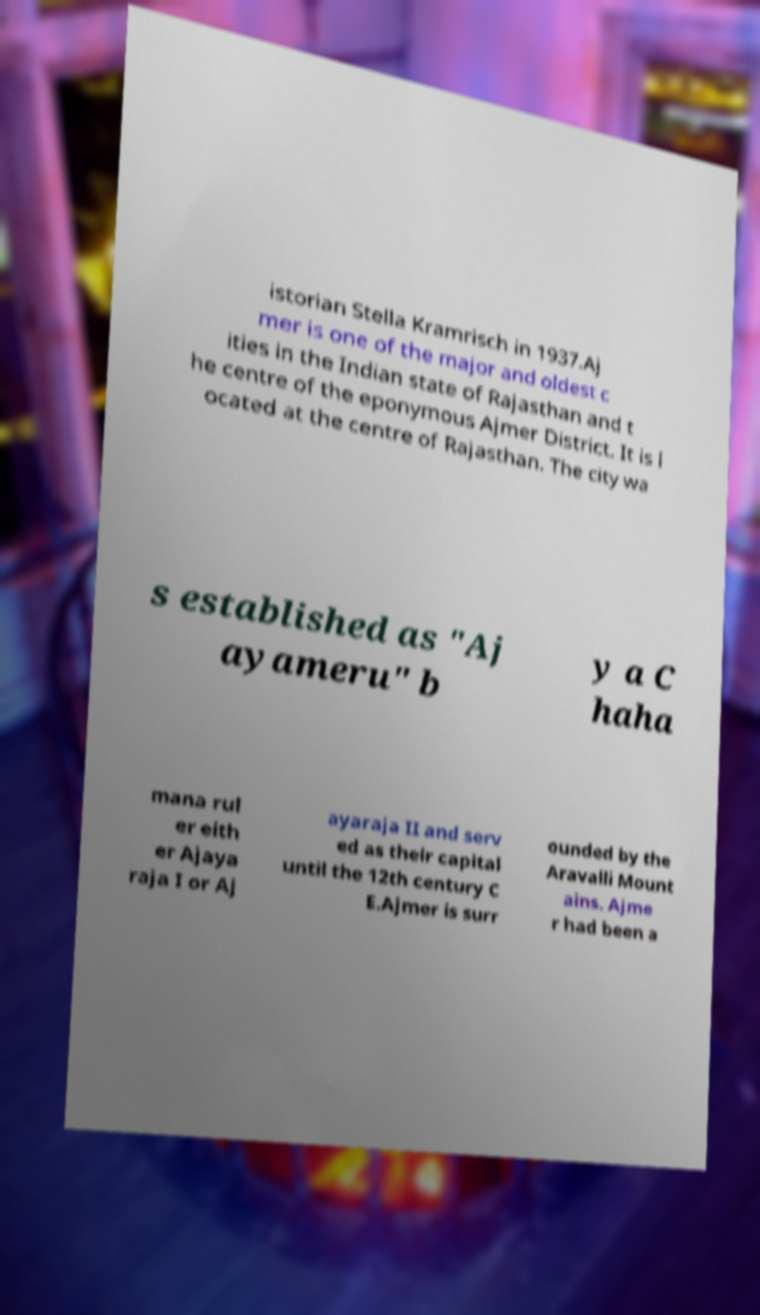For documentation purposes, I need the text within this image transcribed. Could you provide that? istorian Stella Kramrisch in 1937.Aj mer is one of the major and oldest c ities in the Indian state of Rajasthan and t he centre of the eponymous Ajmer District. It is l ocated at the centre of Rajasthan. The city wa s established as "Aj ayameru" b y a C haha mana rul er eith er Ajaya raja I or Aj ayaraja II and serv ed as their capital until the 12th century C E.Ajmer is surr ounded by the Aravalli Mount ains. Ajme r had been a 